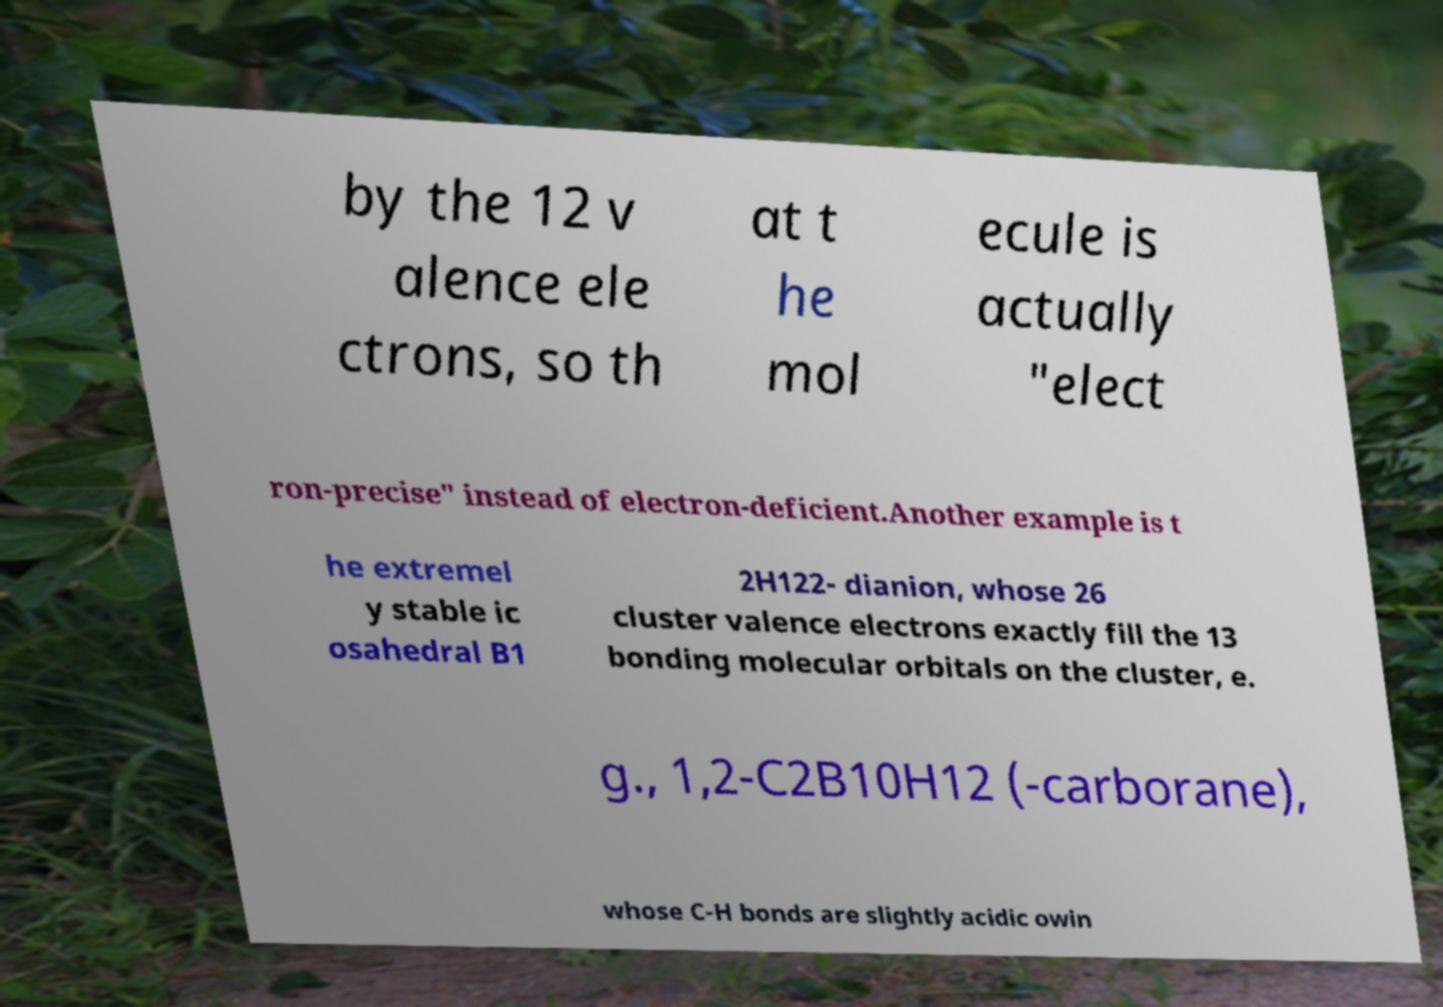What messages or text are displayed in this image? I need them in a readable, typed format. by the 12 v alence ele ctrons, so th at t he mol ecule is actually "elect ron-precise" instead of electron-deficient.Another example is t he extremel y stable ic osahedral B1 2H122- dianion, whose 26 cluster valence electrons exactly fill the 13 bonding molecular orbitals on the cluster, e. g., 1,2-C2B10H12 (-carborane), whose C-H bonds are slightly acidic owin 